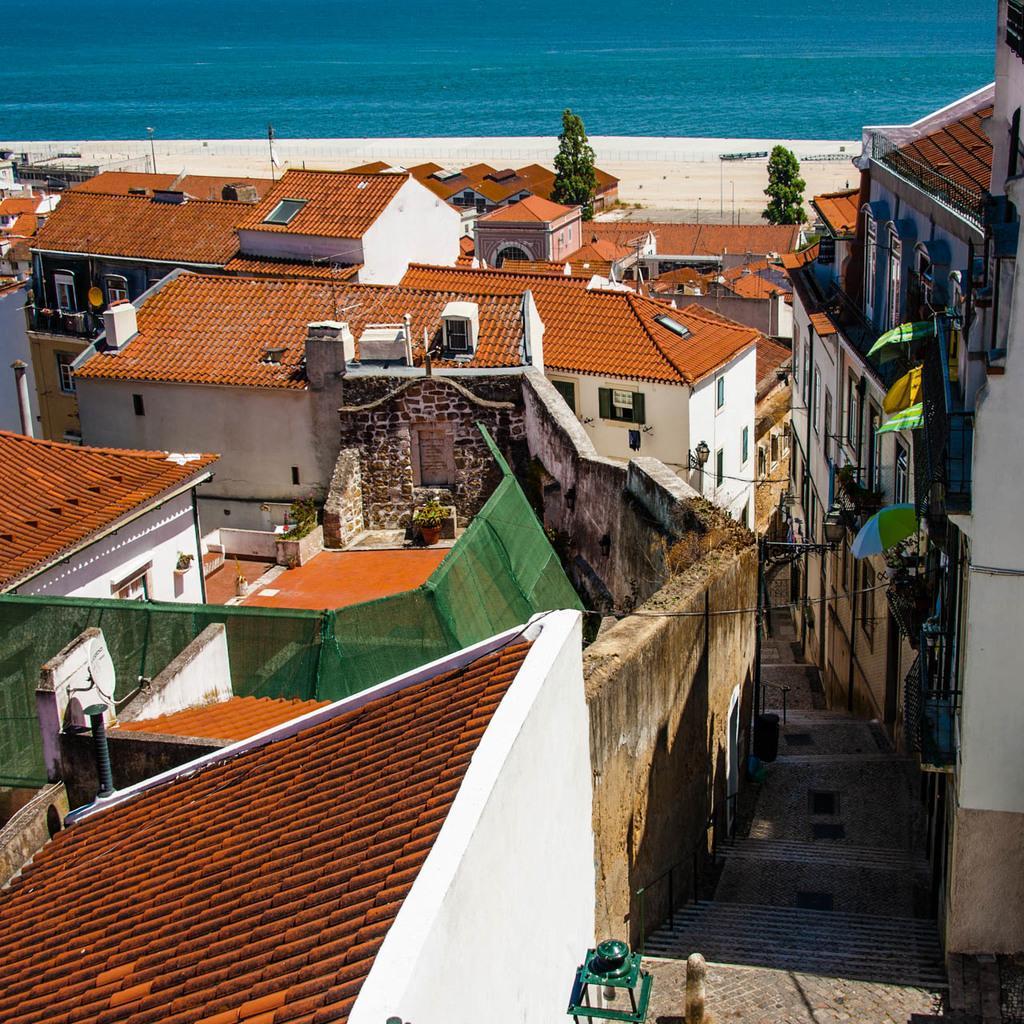Please provide a concise description of this image. This image consists of houses, buildings, trees, fence, windows, light poles, beach, steps, lamp and water. This image is taken may be near the ocean. 